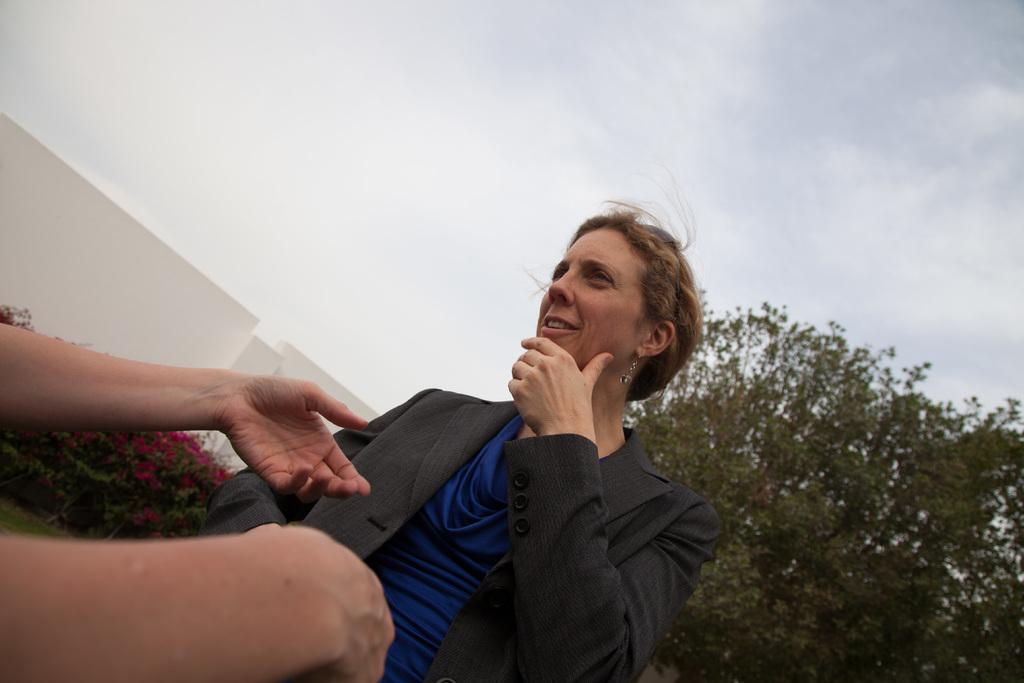Who is present in the image? There is a woman in the image. What is the woman doing in the image? The woman is on a path. Can you describe the hands visible in front of the woman? There are a person's hands visible in front of the woman. What can be seen in the background of the image? There are trees, a wall, and a cloudy sky in the background of the image. What type of nut is being used as a business card holder in the image? There is no nut or business card holder present in the image. 